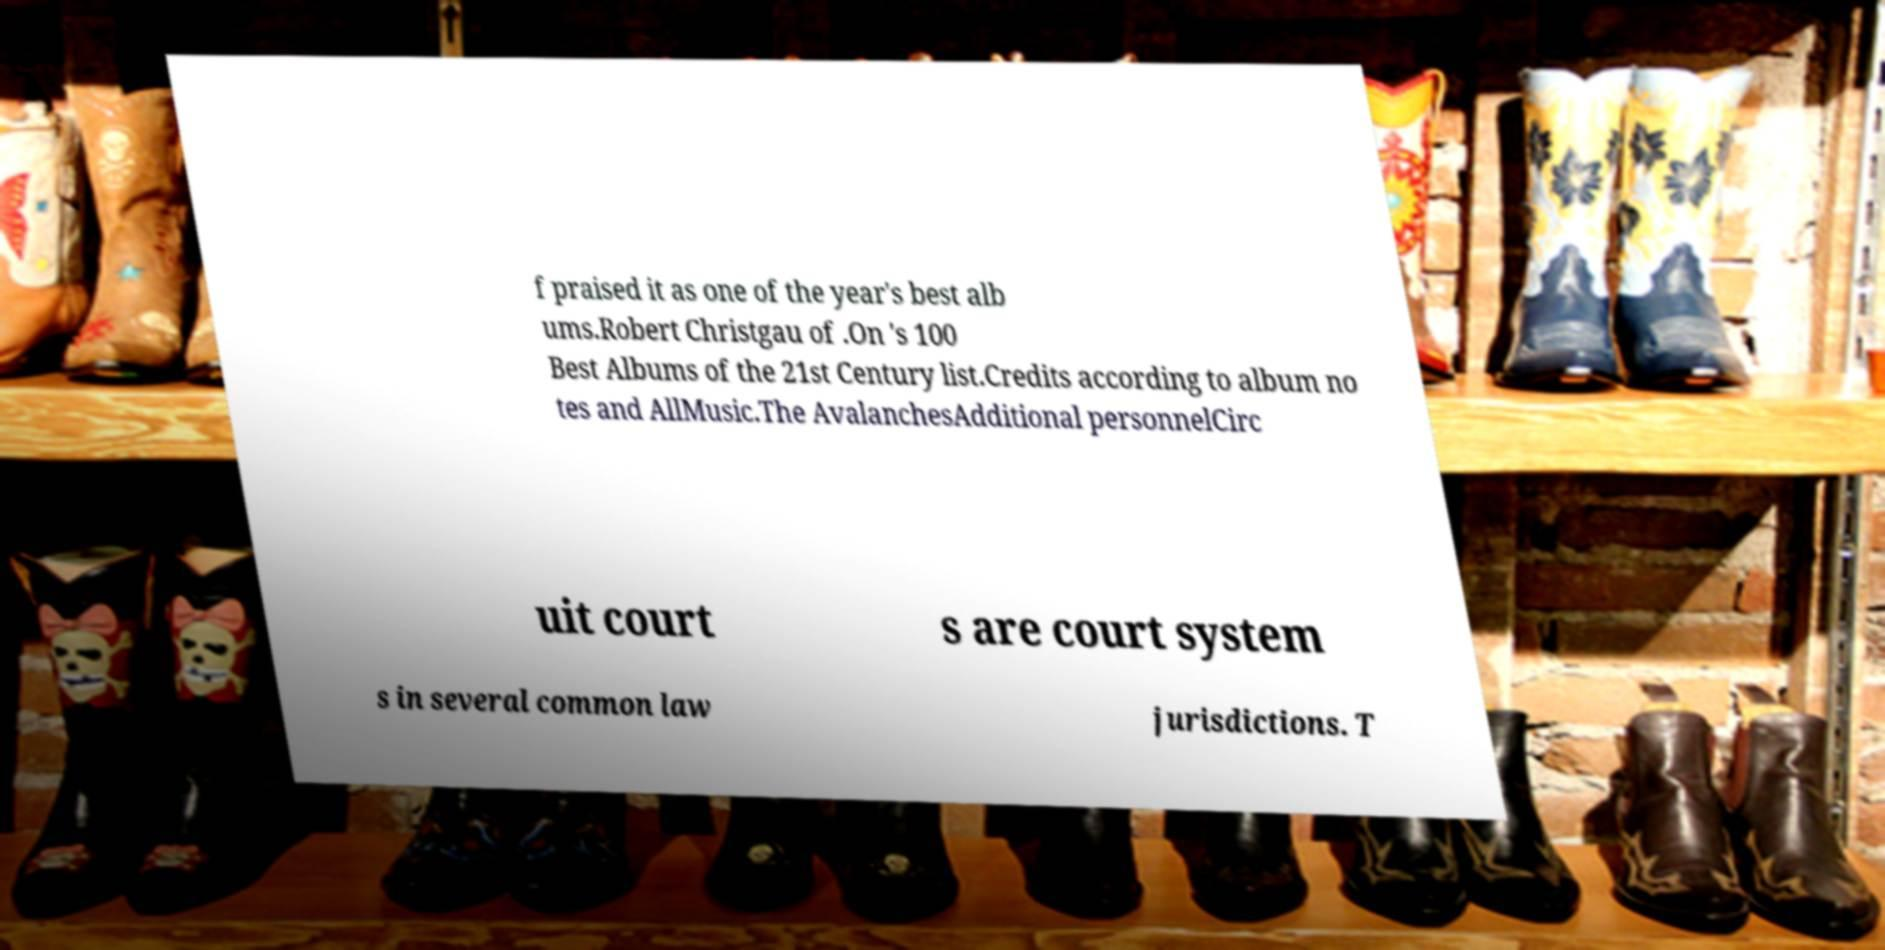Please read and relay the text visible in this image. What does it say? f praised it as one of the year's best alb ums.Robert Christgau of .On 's 100 Best Albums of the 21st Century list.Credits according to album no tes and AllMusic.The AvalanchesAdditional personnelCirc uit court s are court system s in several common law jurisdictions. T 